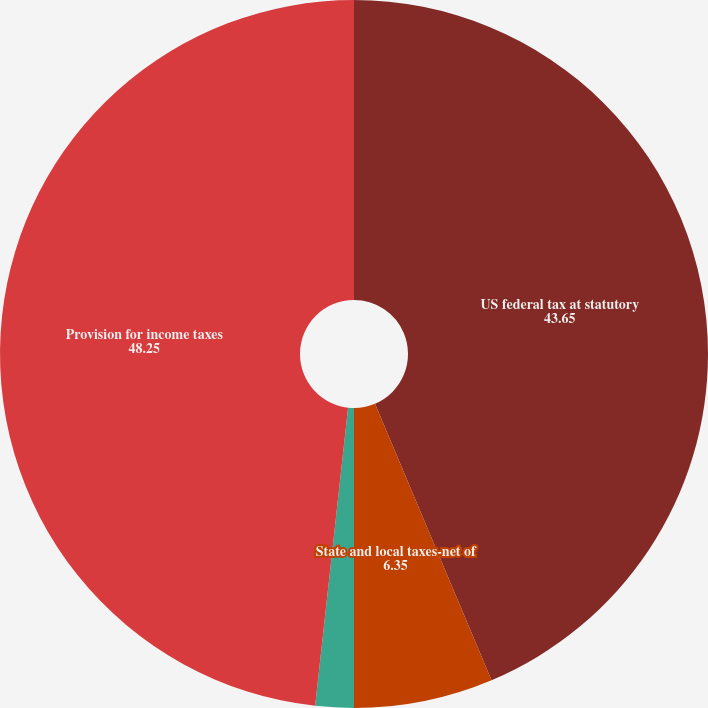<chart> <loc_0><loc_0><loc_500><loc_500><pie_chart><fcel>US federal tax at statutory<fcel>State and local taxes-net of<fcel>Other net<fcel>Provision for income taxes<nl><fcel>43.65%<fcel>6.35%<fcel>1.75%<fcel>48.25%<nl></chart> 